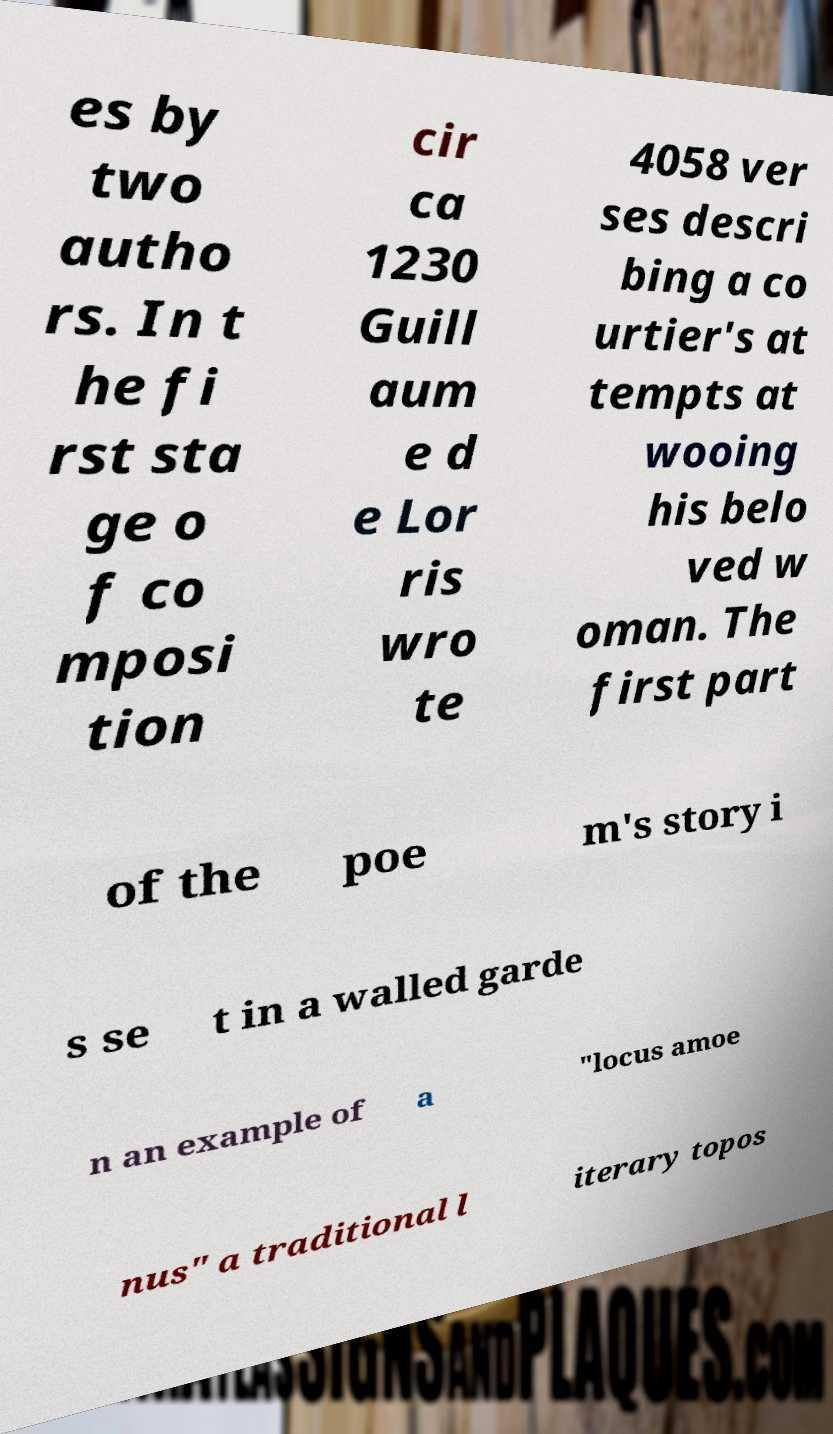What messages or text are displayed in this image? I need them in a readable, typed format. es by two autho rs. In t he fi rst sta ge o f co mposi tion cir ca 1230 Guill aum e d e Lor ris wro te 4058 ver ses descri bing a co urtier's at tempts at wooing his belo ved w oman. The first part of the poe m's story i s se t in a walled garde n an example of a "locus amoe nus" a traditional l iterary topos 